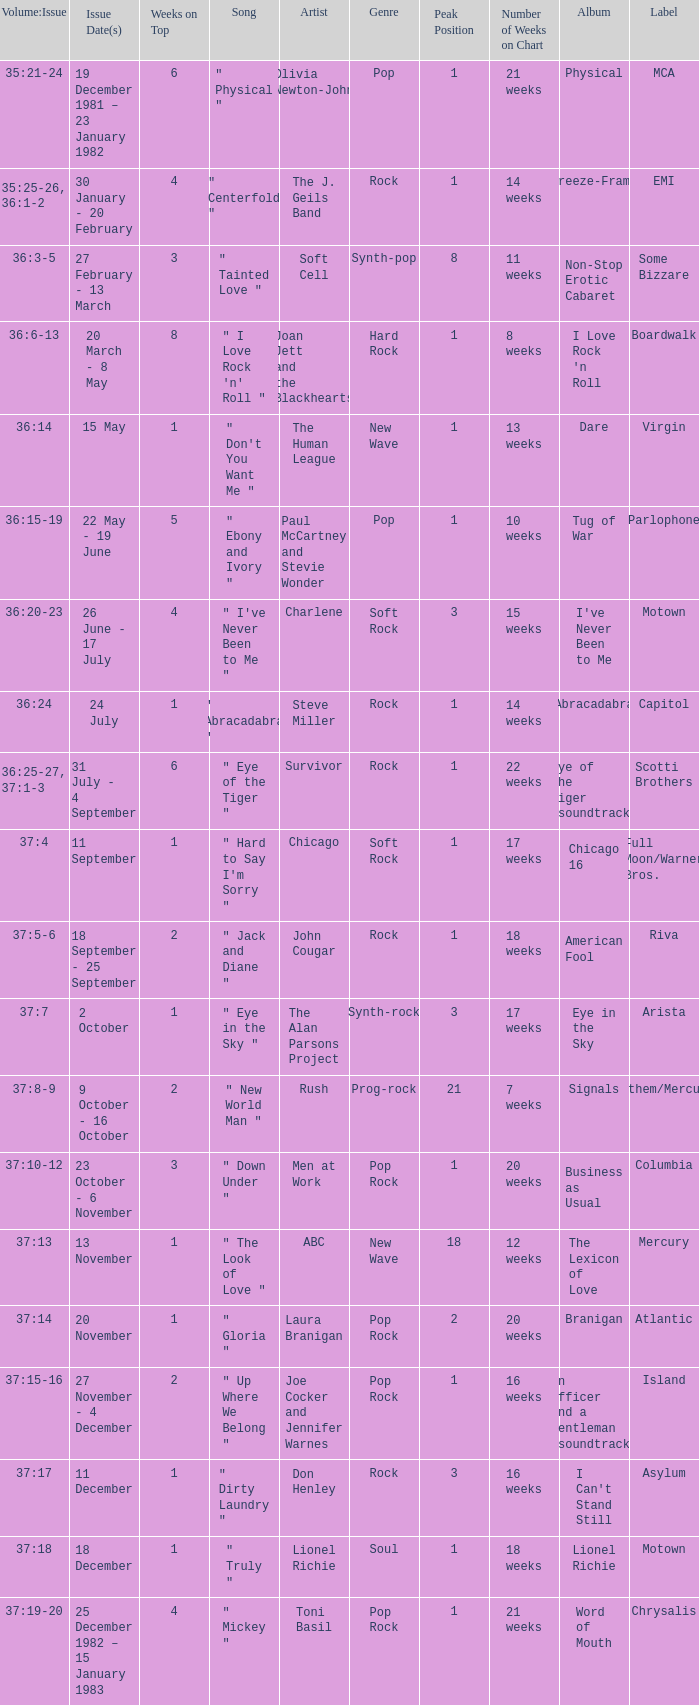Which Issue Date(s) has an Artist of men at work? 23 October - 6 November. 